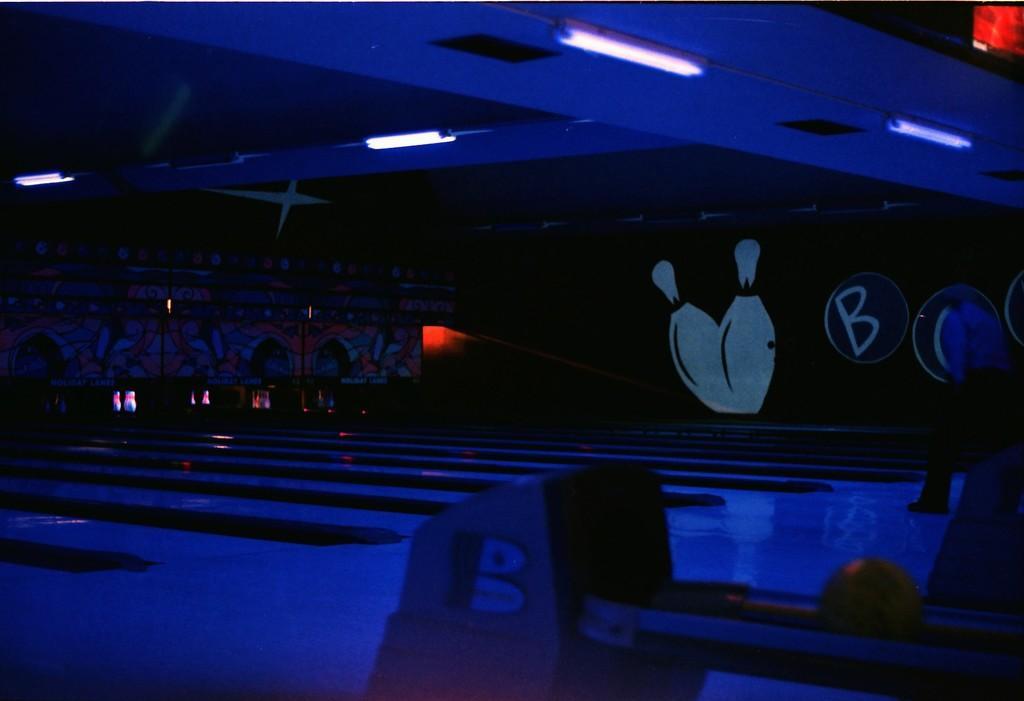In one or two sentences, can you explain what this image depicts? In the picture I can see lights on the ceiling, wall which has some paintings and some other objects on the floor. This image is little bit dark. 